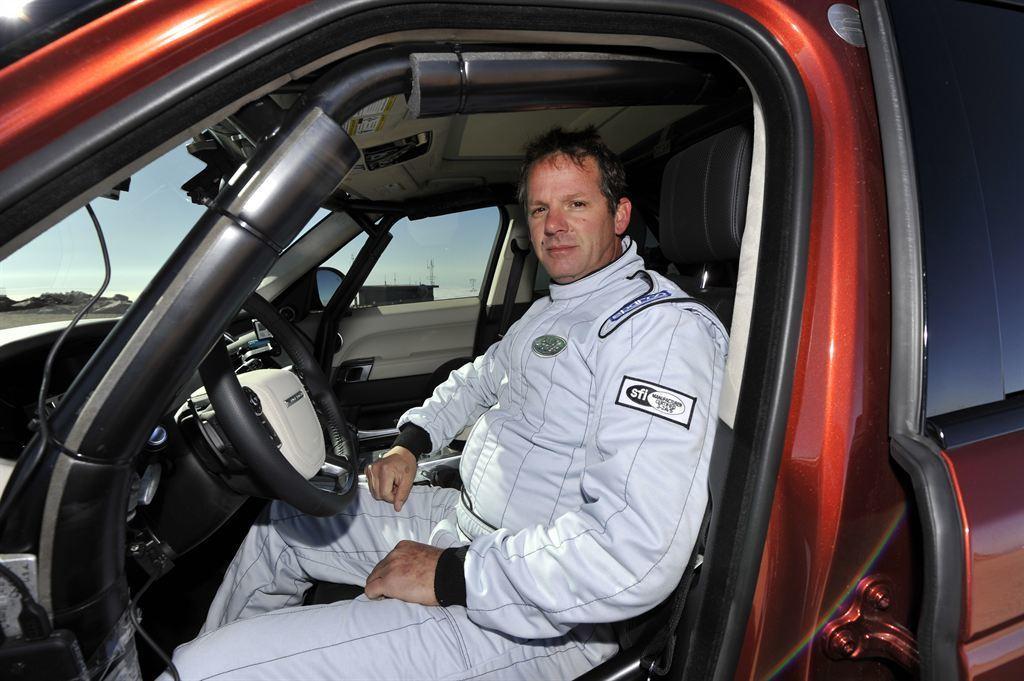How would you summarize this image in a sentence or two? In this picture we can see a man sitting inside a vehicle. From the glass we can see sky. 